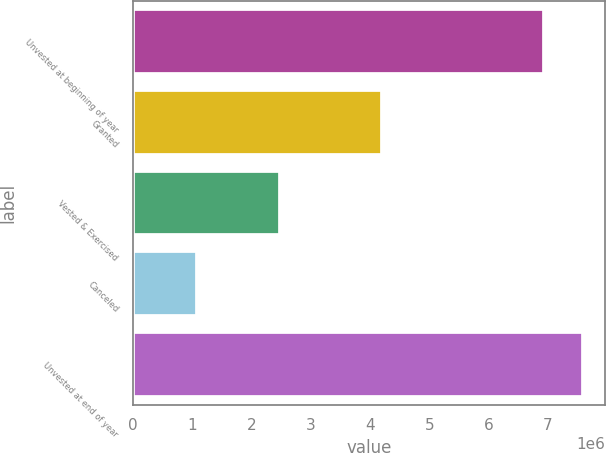Convert chart to OTSL. <chart><loc_0><loc_0><loc_500><loc_500><bar_chart><fcel>Unvested at beginning of year<fcel>Granted<fcel>Vested & Exercised<fcel>Canceled<fcel>Unvested at end of year<nl><fcel>6.93353e+06<fcel>4.19862e+06<fcel>2.47237e+06<fcel>1.08694e+06<fcel>7.58212e+06<nl></chart> 